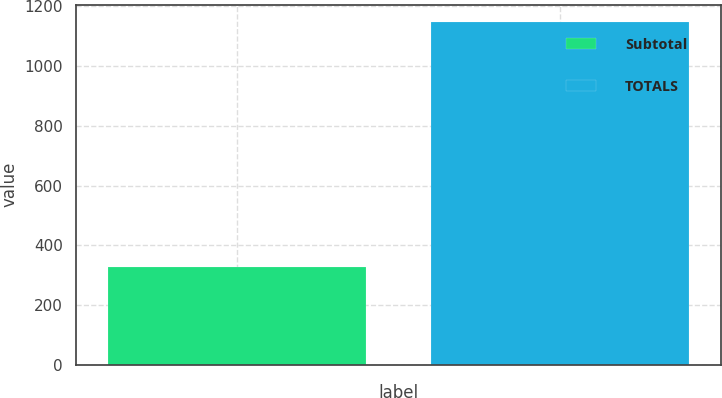Convert chart to OTSL. <chart><loc_0><loc_0><loc_500><loc_500><bar_chart><fcel>Subtotal<fcel>TOTALS<nl><fcel>328.6<fcel>1148.4<nl></chart> 